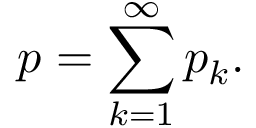Convert formula to latex. <formula><loc_0><loc_0><loc_500><loc_500>p = \sum _ { k = 1 } ^ { \infty } { p _ { k } } .</formula> 